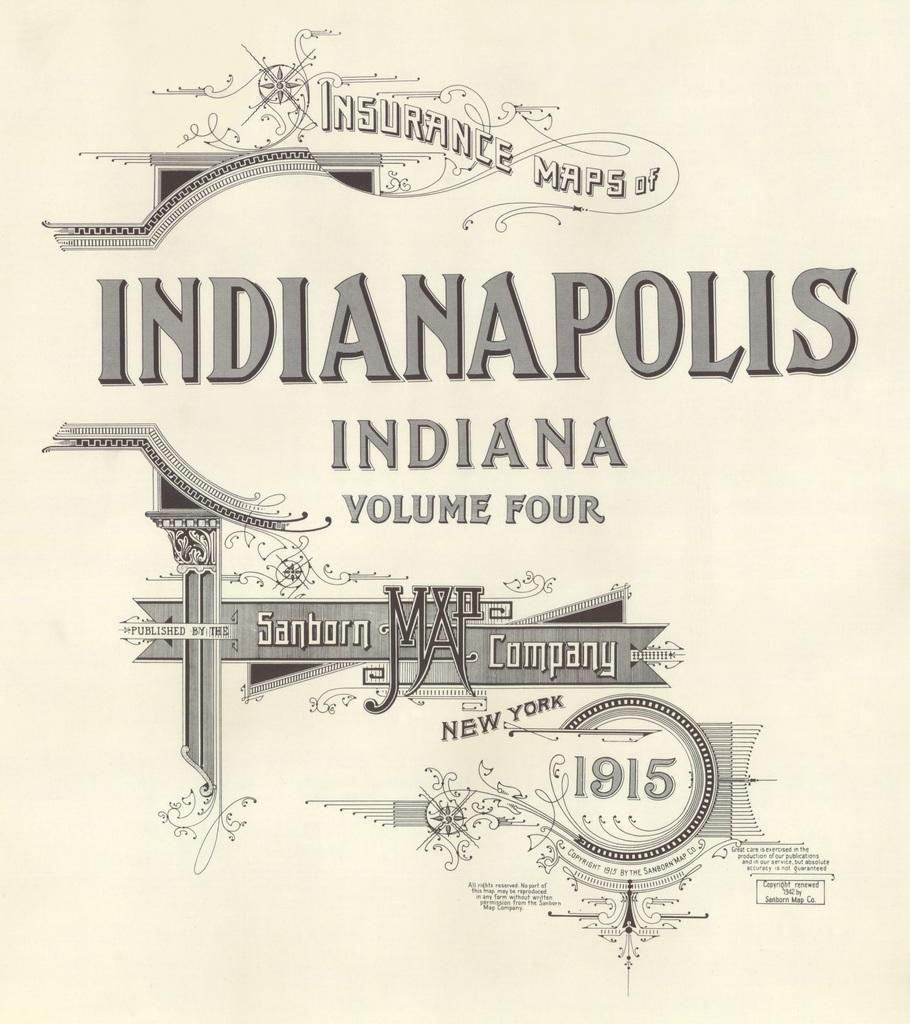<image>
Render a clear and concise summary of the photo. An old insurance map of Indianapolis, Indiana dated 1915 by the Sanborn Map Company in New York. 